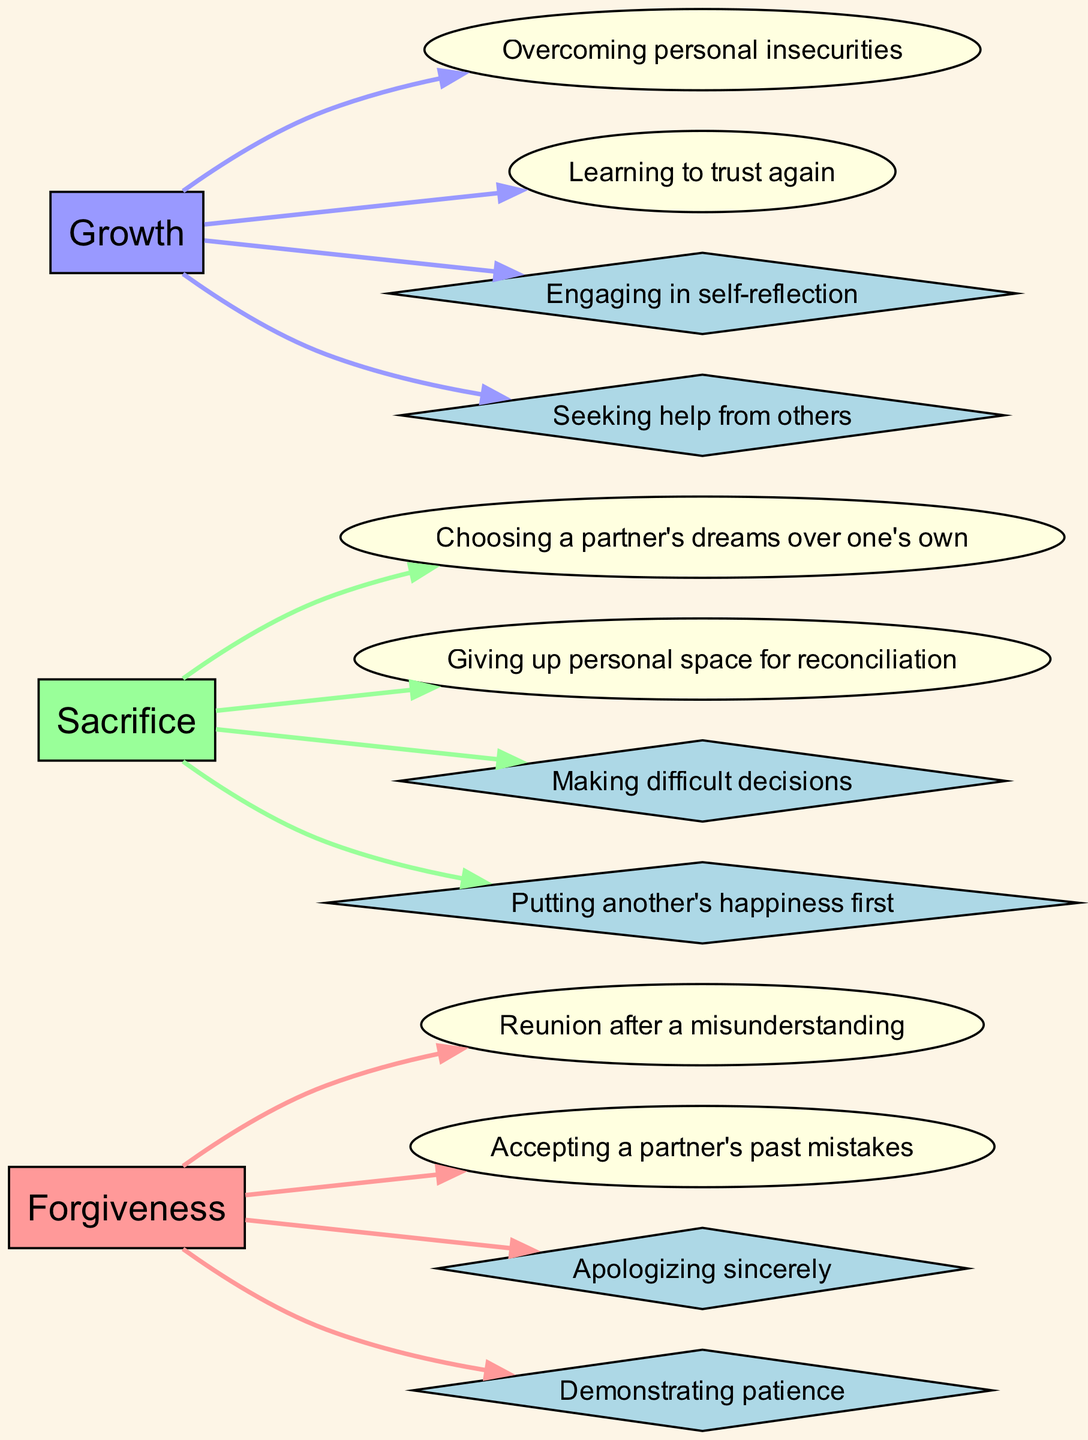What are the two examples listed under "Forgiveness"? The diagram illustrates that the examples for "Forgiveness" are "Reunion after a misunderstanding" and "Accepting a partner's past mistakes." These are directly connected to the theme node in the diagram.
Answer: Reunion after a misunderstanding, Accepting a partner's past mistakes How many character actions are associated with the theme of "Growth"? By examining the diagram, we see that there are two character actions linked to the "Growth" theme, specifically "Engaging in self-reflection" and "Seeking help from others." Each action is represented as a node connected to the theme node.
Answer: 2 Which theme has the example "Giving up personal space for reconciliation"? The example "Giving up personal space for reconciliation" is associated with the theme of "Sacrifice," as shown in the diagram where this example links directly from the "Sacrifice" theme node.
Answer: Sacrifice What is the description of the theme "Forgiveness"? The diagram specifies that the description of "Forgiveness" is "The act of releasing resentment or vengeance towards someone who has wronged the character." This can be found as part of the information connected to the theme node itself.
Answer: The act of releasing resentment or vengeance towards someone who has wronged the character Which character action is associated with the theme "Sacrifice"? The diagram shows that one of the character actions associated with "Sacrifice" is "Putting another's happiness first." This action flows from the "Sacrifice" theme node in the diagram context.
Answer: Putting another's happiness first How many themes are represented in the diagram? The diagram includes three distinct themes: "Forgiveness," "Sacrifice," and "Growth." By counting the theme nodes, we find the total.
Answer: 3 What type of node represents examples in the diagram? In the diagram, examples are represented by ellipse-shaped nodes, which can be identified by their shape and the connections stemming from the theme nodes.
Answer: Ellipse Are there more examples listed for "Forgiveness" or "Sacrifice"? The diagram contains two examples for "Forgiveness" and two examples for "Sacrifice," thus both themes have the same quantity when comparing examples.
Answer: Equal 